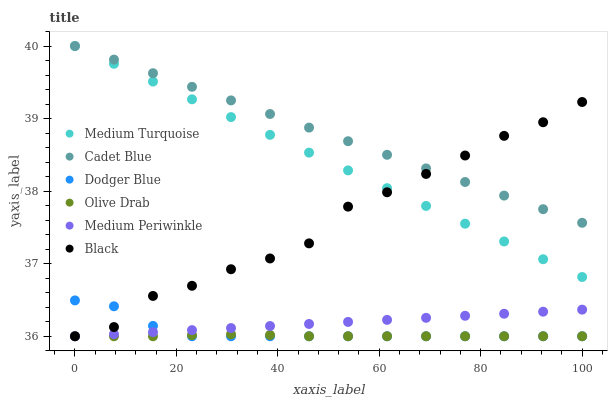Does Olive Drab have the minimum area under the curve?
Answer yes or no. Yes. Does Cadet Blue have the maximum area under the curve?
Answer yes or no. Yes. Does Medium Periwinkle have the minimum area under the curve?
Answer yes or no. No. Does Medium Periwinkle have the maximum area under the curve?
Answer yes or no. No. Is Cadet Blue the smoothest?
Answer yes or no. Yes. Is Black the roughest?
Answer yes or no. Yes. Is Medium Periwinkle the smoothest?
Answer yes or no. No. Is Medium Periwinkle the roughest?
Answer yes or no. No. Does Medium Periwinkle have the lowest value?
Answer yes or no. Yes. Does Medium Turquoise have the lowest value?
Answer yes or no. No. Does Medium Turquoise have the highest value?
Answer yes or no. Yes. Does Medium Periwinkle have the highest value?
Answer yes or no. No. Is Dodger Blue less than Medium Turquoise?
Answer yes or no. Yes. Is Medium Turquoise greater than Olive Drab?
Answer yes or no. Yes. Does Olive Drab intersect Dodger Blue?
Answer yes or no. Yes. Is Olive Drab less than Dodger Blue?
Answer yes or no. No. Is Olive Drab greater than Dodger Blue?
Answer yes or no. No. Does Dodger Blue intersect Medium Turquoise?
Answer yes or no. No. 